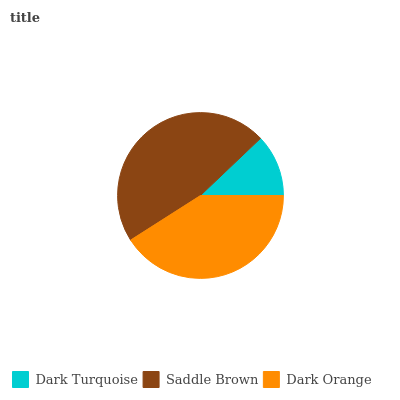Is Dark Turquoise the minimum?
Answer yes or no. Yes. Is Saddle Brown the maximum?
Answer yes or no. Yes. Is Dark Orange the minimum?
Answer yes or no. No. Is Dark Orange the maximum?
Answer yes or no. No. Is Saddle Brown greater than Dark Orange?
Answer yes or no. Yes. Is Dark Orange less than Saddle Brown?
Answer yes or no. Yes. Is Dark Orange greater than Saddle Brown?
Answer yes or no. No. Is Saddle Brown less than Dark Orange?
Answer yes or no. No. Is Dark Orange the high median?
Answer yes or no. Yes. Is Dark Orange the low median?
Answer yes or no. Yes. Is Dark Turquoise the high median?
Answer yes or no. No. Is Saddle Brown the low median?
Answer yes or no. No. 